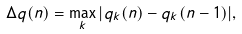<formula> <loc_0><loc_0><loc_500><loc_500>\Delta q ( n ) = \max _ { k } | q _ { k } ( n ) - q _ { k } ( n - 1 ) | ,</formula> 